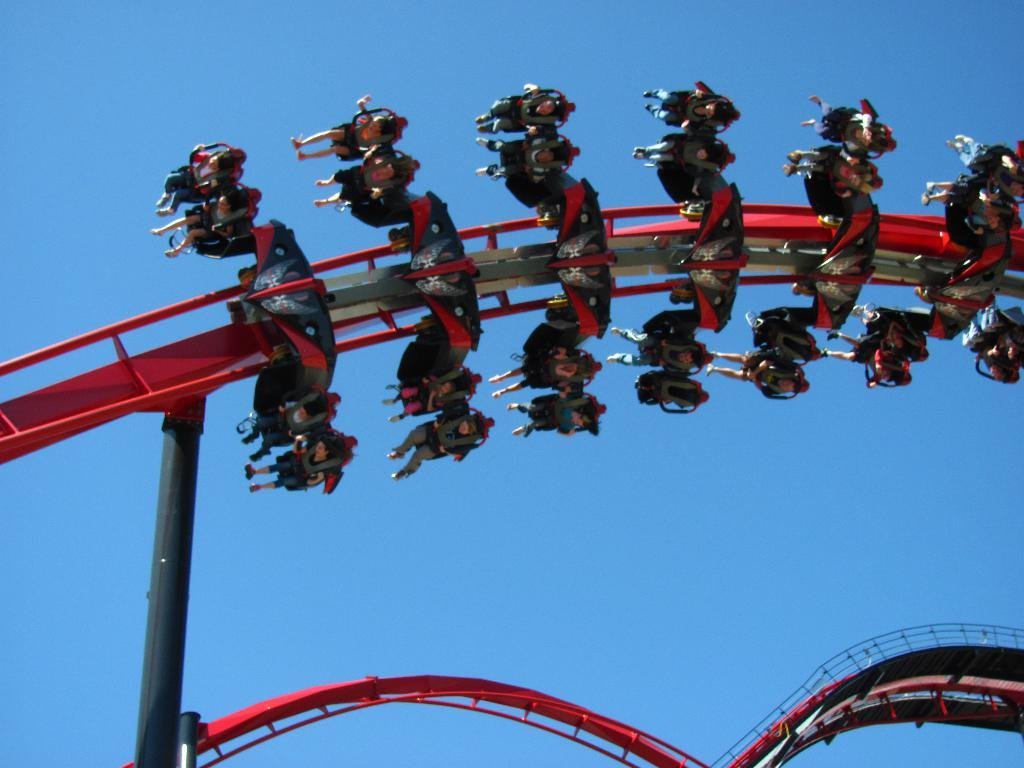What is happening to the group of people in the image? The people are sitting in a roller coaster. What can be seen supporting the roller coaster in the image? There are poles visible in the image. What is visible in the background of the image? The sky is visible in the background of the image. How would you describe the weather based on the sky in the image? The sky appears to be cloudy in the image. Can you see any boats in the image? No, there are no boats present in the image. Are there any oranges visible in the image? No, there are no oranges present in the image. 